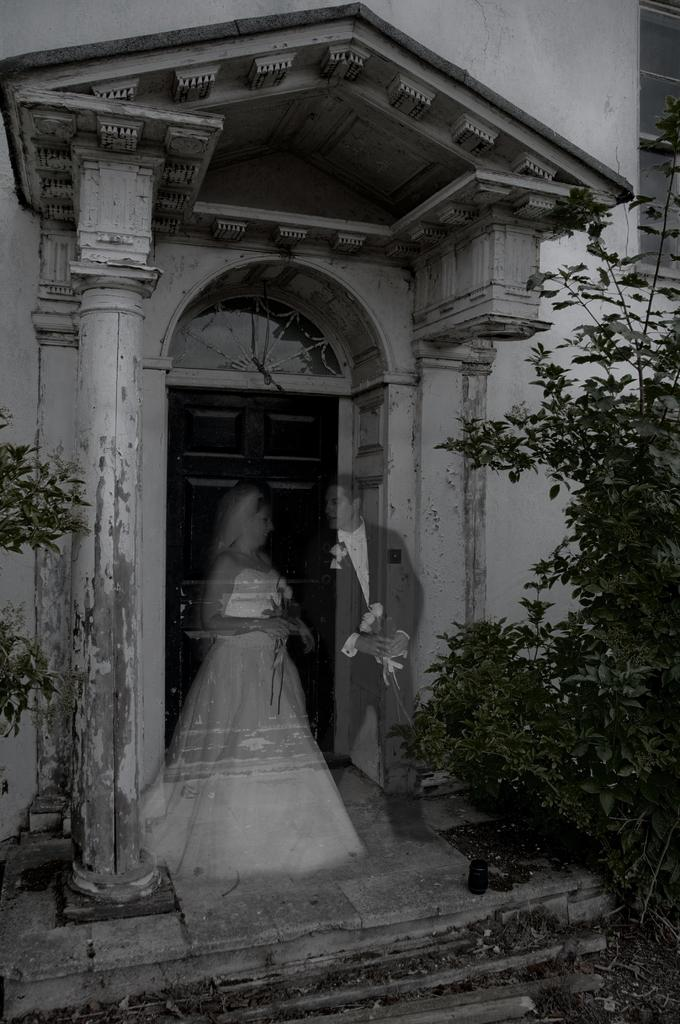What can be seen in the foreground of the picture? There are plants and a staircase in the foreground of the picture. What is the main subject in the center of the picture? There is a couple in the center of the picture. What type of structure can be seen at the top of the picture? There is a building at the top of the picture, possibly a church. What year is the couple celebrating their anniversary in the image? The image does not provide any information about the couple's anniversary or the year. What type of pet can be seen accompanying the couple in the image? There is no pet present in the image; the main subjects are the couple and the surrounding environment. 